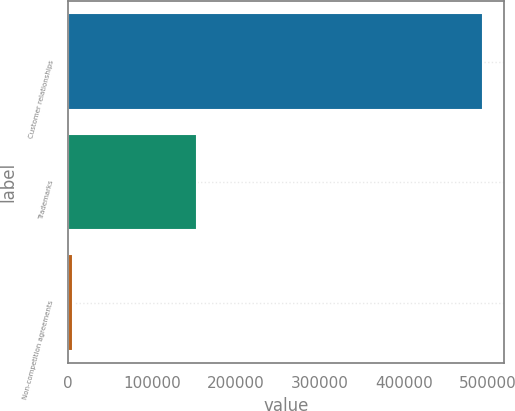Convert chart. <chart><loc_0><loc_0><loc_500><loc_500><bar_chart><fcel>Customer relationships<fcel>Trademarks<fcel>Non-competition agreements<nl><fcel>494516<fcel>153346<fcel>5765<nl></chart> 